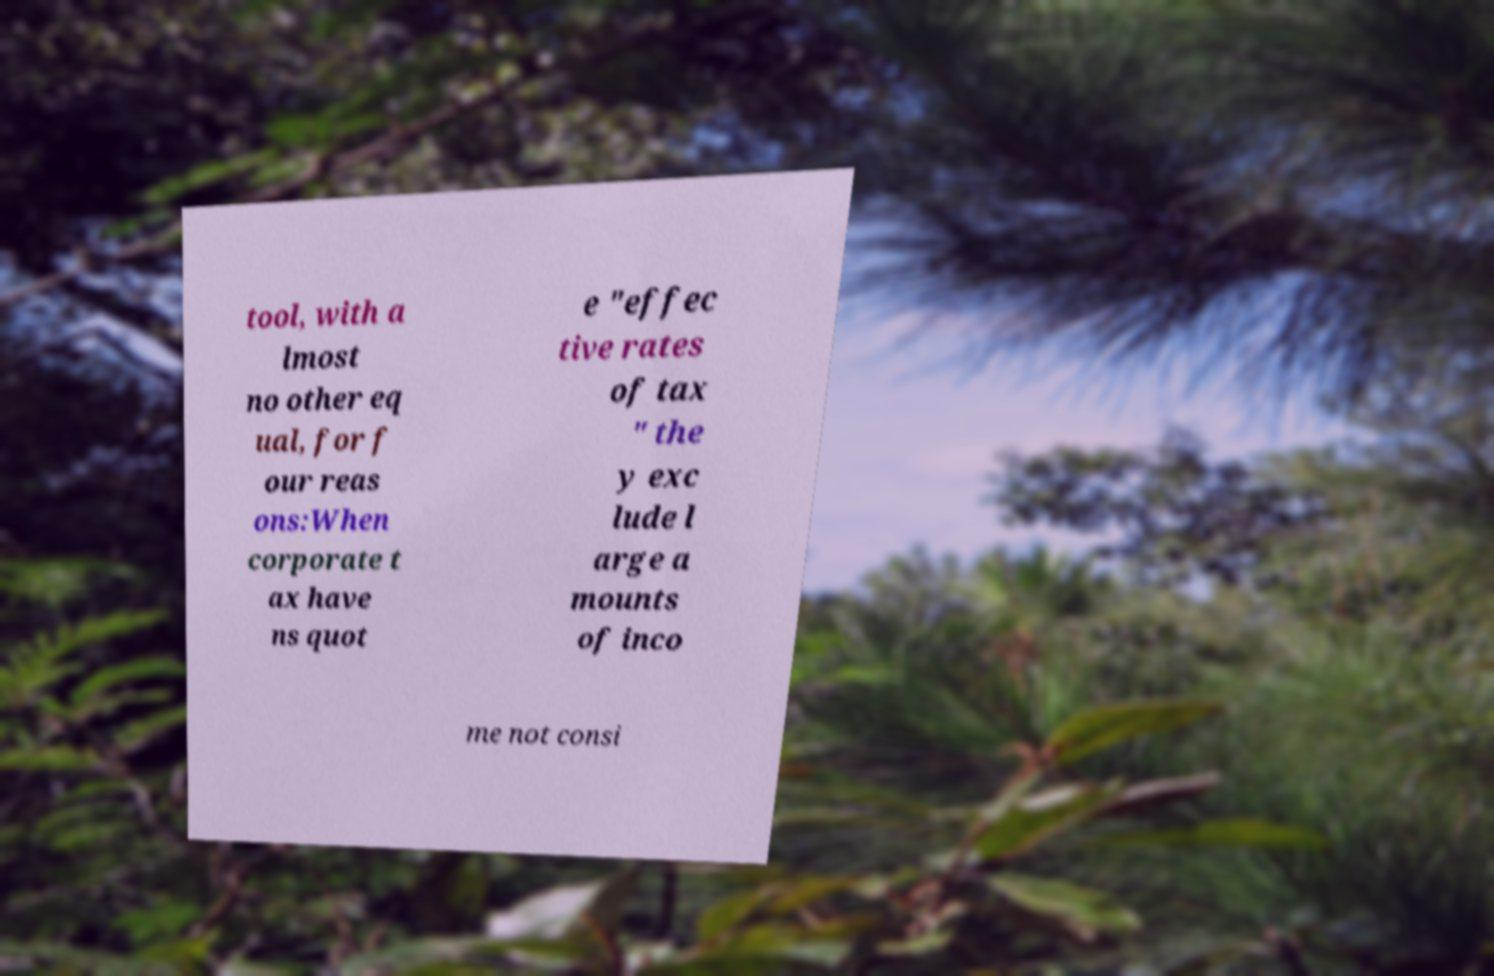There's text embedded in this image that I need extracted. Can you transcribe it verbatim? tool, with a lmost no other eq ual, for f our reas ons:When corporate t ax have ns quot e "effec tive rates of tax " the y exc lude l arge a mounts of inco me not consi 